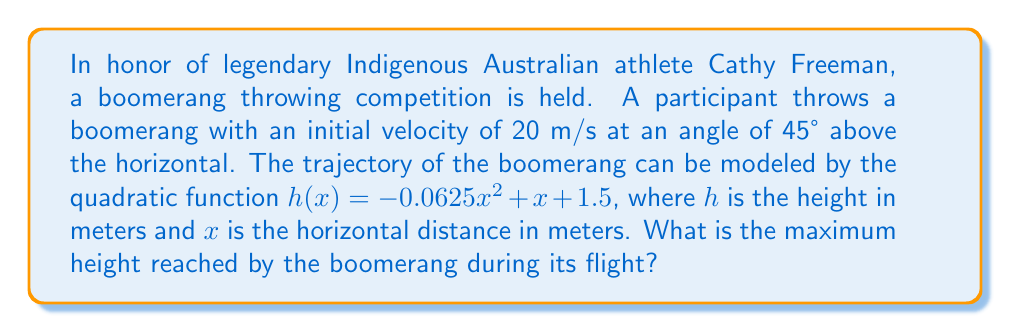What is the answer to this math problem? To find the maximum height of the boomerang's trajectory, we need to follow these steps:

1) The quadratic function given is in the form $h(x) = ax^2 + bx + c$, where:
   $a = -0.0625$
   $b = 1$
   $c = 1.5$

2) For a quadratic function, the x-coordinate of the vertex represents the point where the maximum height is reached. We can find this using the formula:

   $$x = -\frac{b}{2a}$$

3) Substituting our values:

   $$x = -\frac{1}{2(-0.0625)} = 8$$

4) Now that we have the x-coordinate of the vertex, we can find the maximum height by plugging this x-value back into our original function:

   $$h(8) = -0.0625(8)^2 + 1(8) + 1.5$$

5) Simplifying:
   $$h(8) = -0.0625(64) + 8 + 1.5$$
   $$h(8) = -4 + 8 + 1.5$$
   $$h(8) = 5.5$$

Therefore, the maximum height reached by the boomerang is 5.5 meters.
Answer: 5.5 meters 